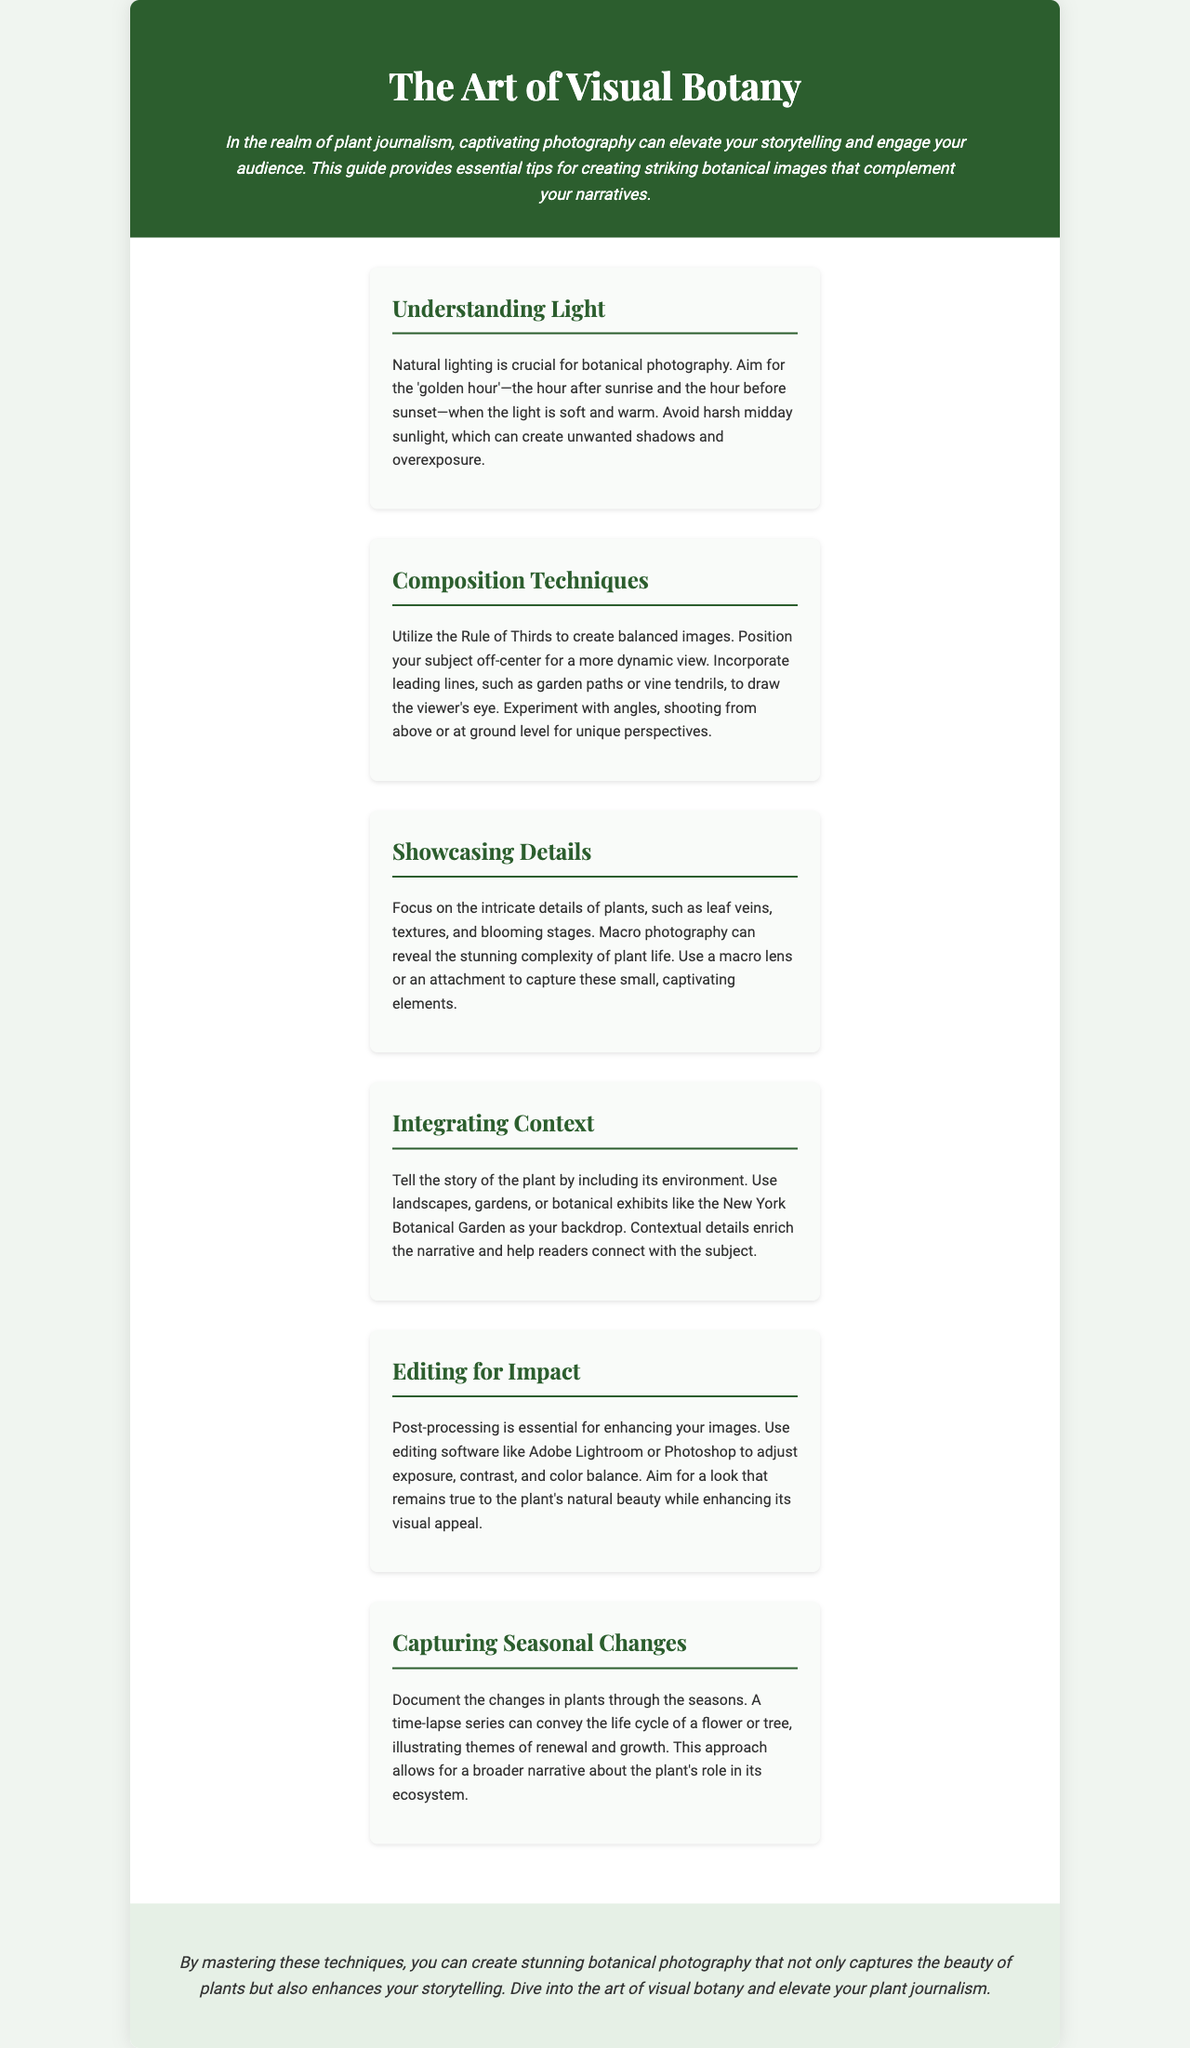what is the title of the brochure? The title of the brochure appears in the header section of the document.
Answer: The Art of Visual Botany what is the focus of the brochure? The brochure's purpose is outlined in the introduction.
Answer: Tips for stunning photography in plant journalism what are the two ideal times for natural lighting in photography? The brochure specifies ideal lighting conditions for photography.
Answer: Golden hour what technique is recommended for image composition? The brochure mentions a specific technique for creating balanced images.
Answer: Rule of Thirds what type of photography reveals intricate details of plants? The brochure suggests a photography style to capture small features.
Answer: Macro photography where can contextual details for plant stories be integrated? The section discusses appropriate backdrops to enrich narratives.
Answer: Landscapes or gardens what software is suggested for photo editing? The brochure lists editing software that enhances images.
Answer: Adobe Lightroom or Photoshop what subject can a time-lapse series illustrate? The brochure describes what themes can be documented through time-lapses.
Answer: Life cycle of a flower or tree what style does the introduction of the brochure use? The introduction's stylistic indication is given in its description.
Answer: Italic font style 